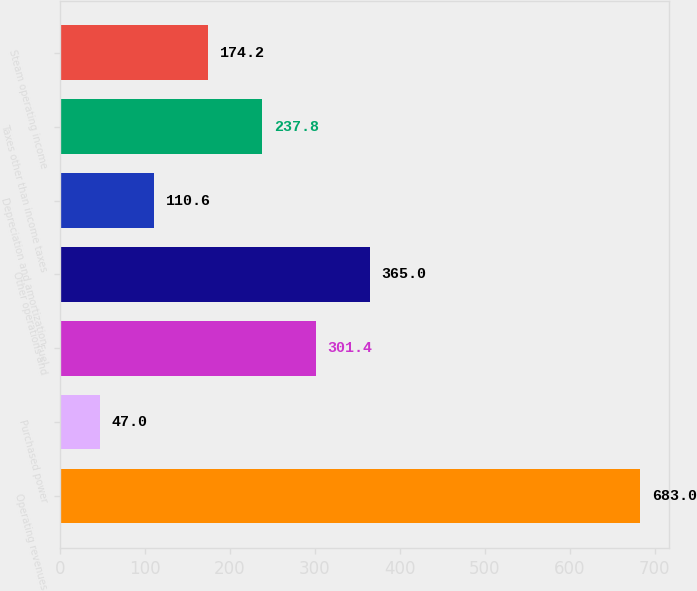<chart> <loc_0><loc_0><loc_500><loc_500><bar_chart><fcel>Operating revenues<fcel>Purchased power<fcel>Fuel<fcel>Other operations and<fcel>Depreciation and amortization<fcel>Taxes other than income taxes<fcel>Steam operating income<nl><fcel>683<fcel>47<fcel>301.4<fcel>365<fcel>110.6<fcel>237.8<fcel>174.2<nl></chart> 